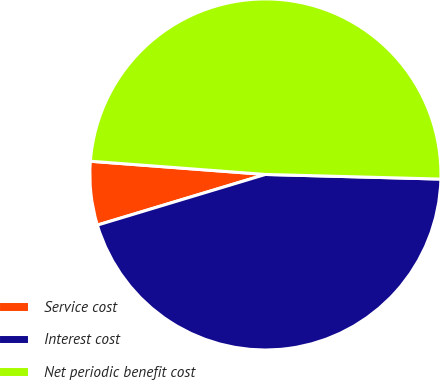<chart> <loc_0><loc_0><loc_500><loc_500><pie_chart><fcel>Service cost<fcel>Interest cost<fcel>Net periodic benefit cost<nl><fcel>5.86%<fcel>44.92%<fcel>49.22%<nl></chart> 